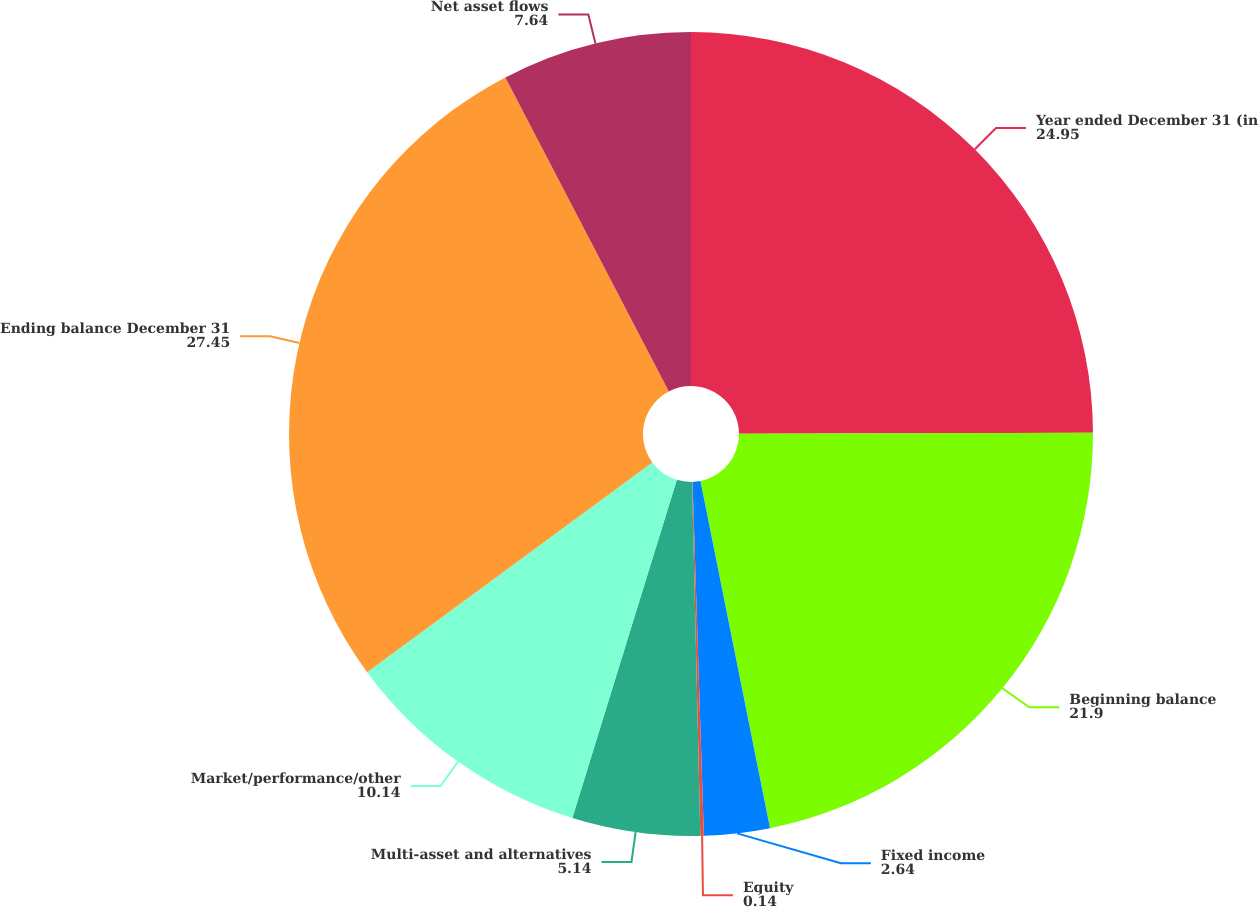Convert chart to OTSL. <chart><loc_0><loc_0><loc_500><loc_500><pie_chart><fcel>Year ended December 31 (in<fcel>Beginning balance<fcel>Fixed income<fcel>Equity<fcel>Multi-asset and alternatives<fcel>Market/performance/other<fcel>Ending balance December 31<fcel>Net asset flows<nl><fcel>24.95%<fcel>21.9%<fcel>2.64%<fcel>0.14%<fcel>5.14%<fcel>10.14%<fcel>27.45%<fcel>7.64%<nl></chart> 